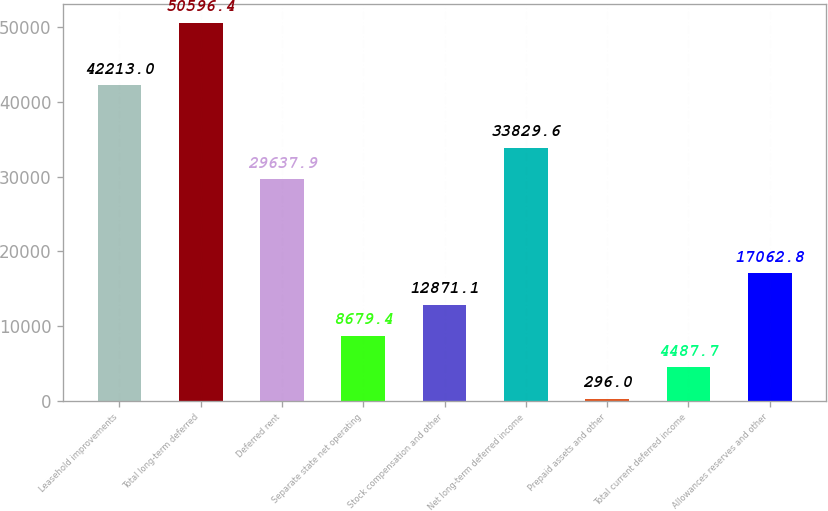Convert chart to OTSL. <chart><loc_0><loc_0><loc_500><loc_500><bar_chart><fcel>Leasehold improvements<fcel>Total long-term deferred<fcel>Deferred rent<fcel>Separate state net operating<fcel>Stock compensation and other<fcel>Net long-term deferred income<fcel>Prepaid assets and other<fcel>Total current deferred income<fcel>Allowances reserves and other<nl><fcel>42213<fcel>50596.4<fcel>29637.9<fcel>8679.4<fcel>12871.1<fcel>33829.6<fcel>296<fcel>4487.7<fcel>17062.8<nl></chart> 